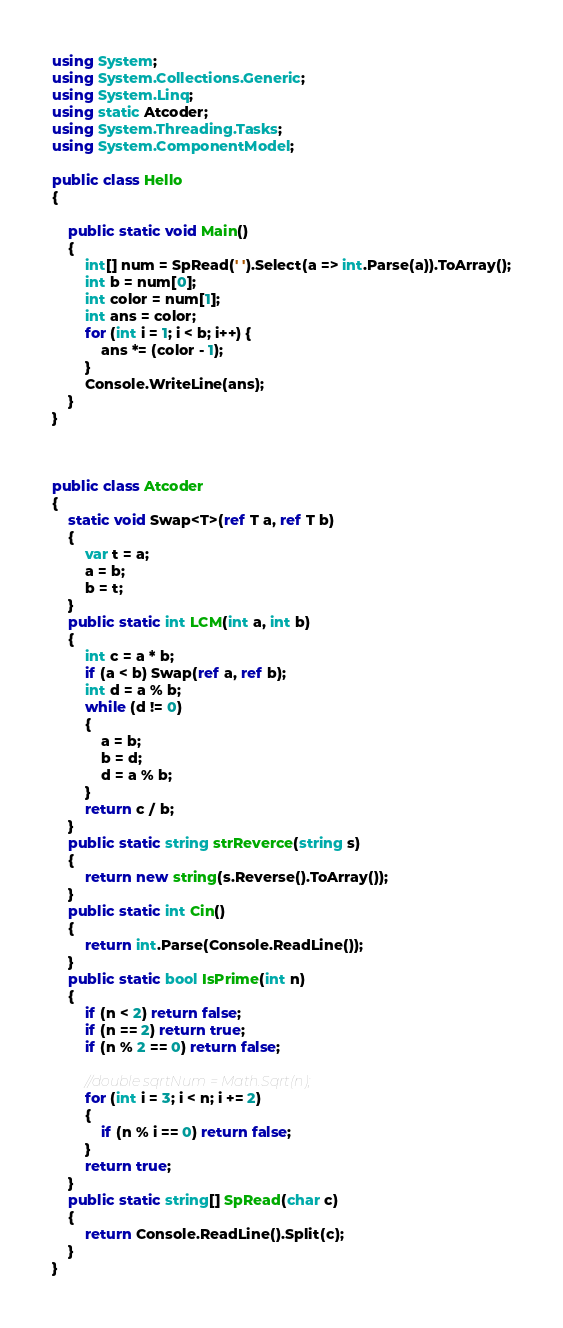<code> <loc_0><loc_0><loc_500><loc_500><_C#_>using System;
using System.Collections.Generic;
using System.Linq;
using static Atcoder;
using System.Threading.Tasks;
using System.ComponentModel;

public class Hello
{

    public static void Main()
    {
        int[] num = SpRead(' ').Select(a => int.Parse(a)).ToArray();
        int b = num[0];
        int color = num[1];
        int ans = color;
        for (int i = 1; i < b; i++) {
            ans *= (color - 1);
        }
        Console.WriteLine(ans);
    }
}



public class Atcoder
{
    static void Swap<T>(ref T a, ref T b)
    {
        var t = a;
        a = b;
        b = t;
    }
    public static int LCM(int a, int b)
    {
        int c = a * b;
        if (a < b) Swap(ref a, ref b);
        int d = a % b;
        while (d != 0)
        {
            a = b;
            b = d;
            d = a % b;
        }
        return c / b;
    }
    public static string strReverce(string s)
    {
        return new string(s.Reverse().ToArray());
    }
    public static int Cin()
    {
        return int.Parse(Console.ReadLine());
    }
    public static bool IsPrime(int n)
    {
        if (n < 2) return false;
        if (n == 2) return true;
        if (n % 2 == 0) return false;

        //double sqrtNum = Math.Sqrt(n);
        for (int i = 3; i < n; i += 2)
        {
            if (n % i == 0) return false;
        }
        return true;
    }
    public static string[] SpRead(char c)
    {
        return Console.ReadLine().Split(c);
    }
}
</code> 